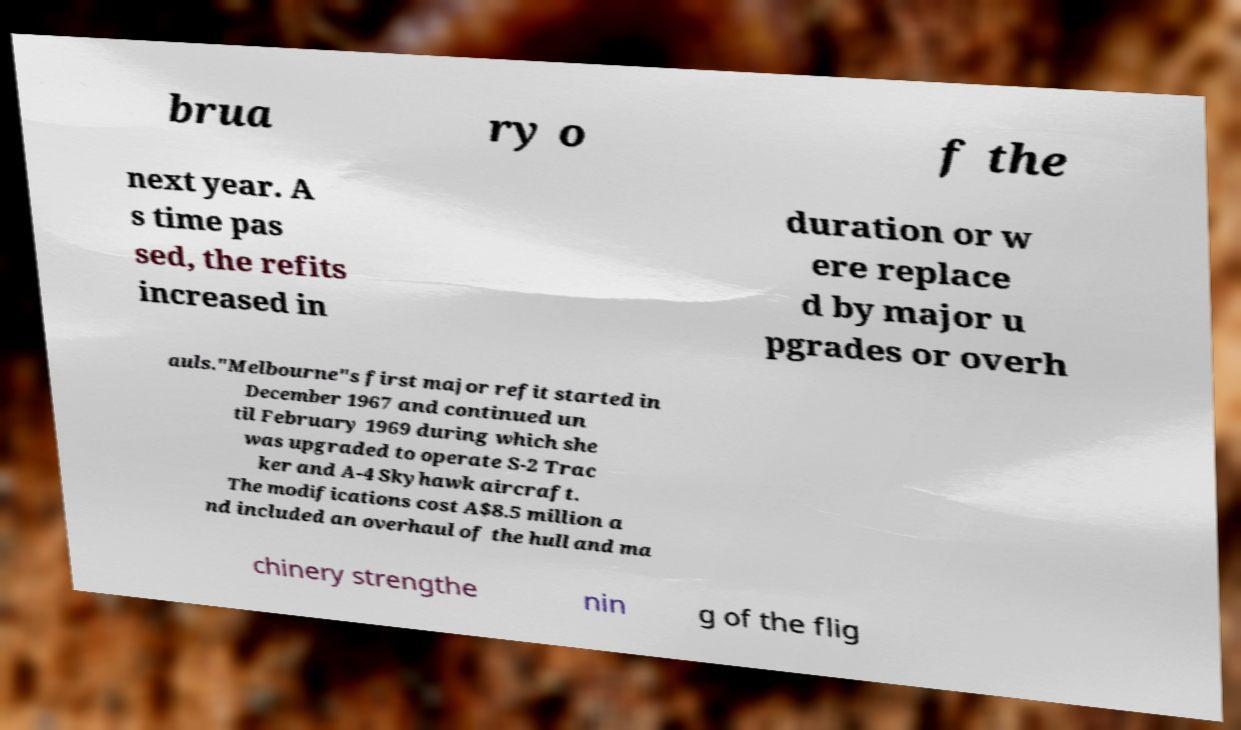Can you accurately transcribe the text from the provided image for me? brua ry o f the next year. A s time pas sed, the refits increased in duration or w ere replace d by major u pgrades or overh auls."Melbourne"s first major refit started in December 1967 and continued un til February 1969 during which she was upgraded to operate S-2 Trac ker and A-4 Skyhawk aircraft. The modifications cost A$8.5 million a nd included an overhaul of the hull and ma chinery strengthe nin g of the flig 